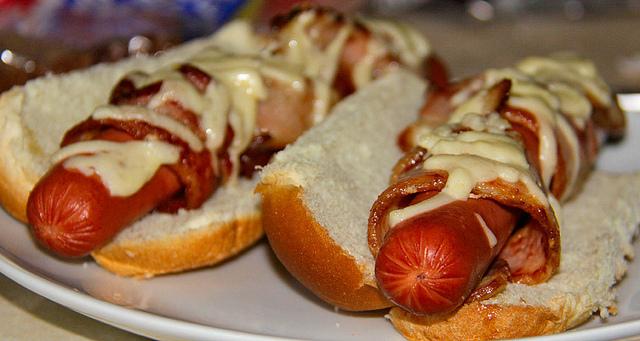Does this look like a healthy meal?
Concise answer only. No. Is the food homemade?
Write a very short answer. Yes. Is this breakfast?
Write a very short answer. No. How many hot dogs are there?
Be succinct. 2. Is the hot dog in a paper plate?
Keep it brief. No. 